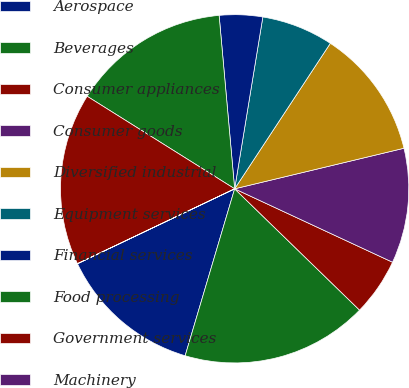Convert chart. <chart><loc_0><loc_0><loc_500><loc_500><pie_chart><fcel>Aerospace<fcel>Beverages<fcel>Consumer appliances<fcel>Consumer goods<fcel>Diversified industrial<fcel>Equipment services<fcel>Financial services<fcel>Food processing<fcel>Government services<fcel>Machinery<nl><fcel>13.33%<fcel>17.32%<fcel>5.34%<fcel>10.67%<fcel>12.0%<fcel>6.67%<fcel>4.01%<fcel>14.66%<fcel>15.99%<fcel>0.01%<nl></chart> 